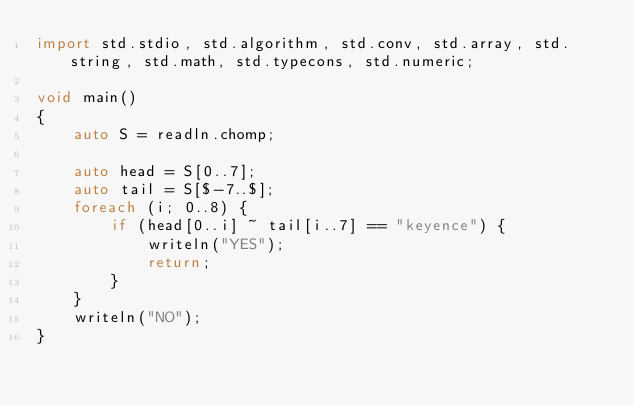<code> <loc_0><loc_0><loc_500><loc_500><_D_>import std.stdio, std.algorithm, std.conv, std.array, std.string, std.math, std.typecons, std.numeric;

void main()
{
    auto S = readln.chomp;

    auto head = S[0..7];
    auto tail = S[$-7..$];
    foreach (i; 0..8) {
        if (head[0..i] ~ tail[i..7] == "keyence") {
            writeln("YES");
            return;
        }
    }
    writeln("NO");
}</code> 